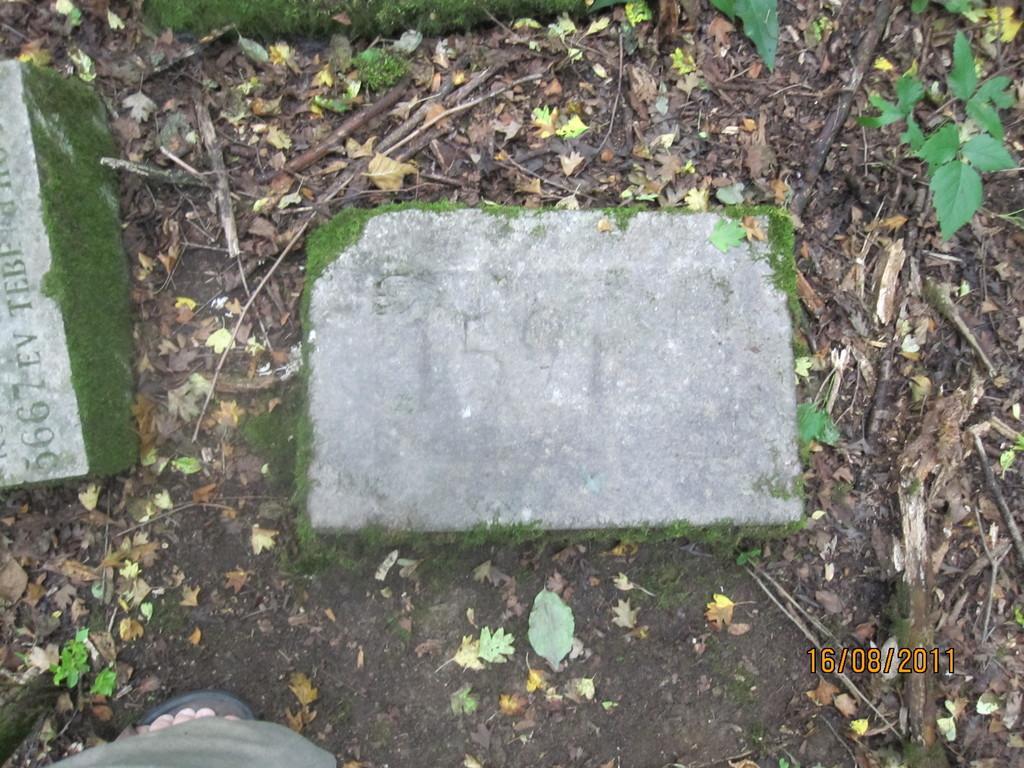Describe this image in one or two sentences. In this picture I can see a human leg and couple of stones and I can see text on one of the stone and a number on another stone and I can see a date on the bottom right corner of the picture. 